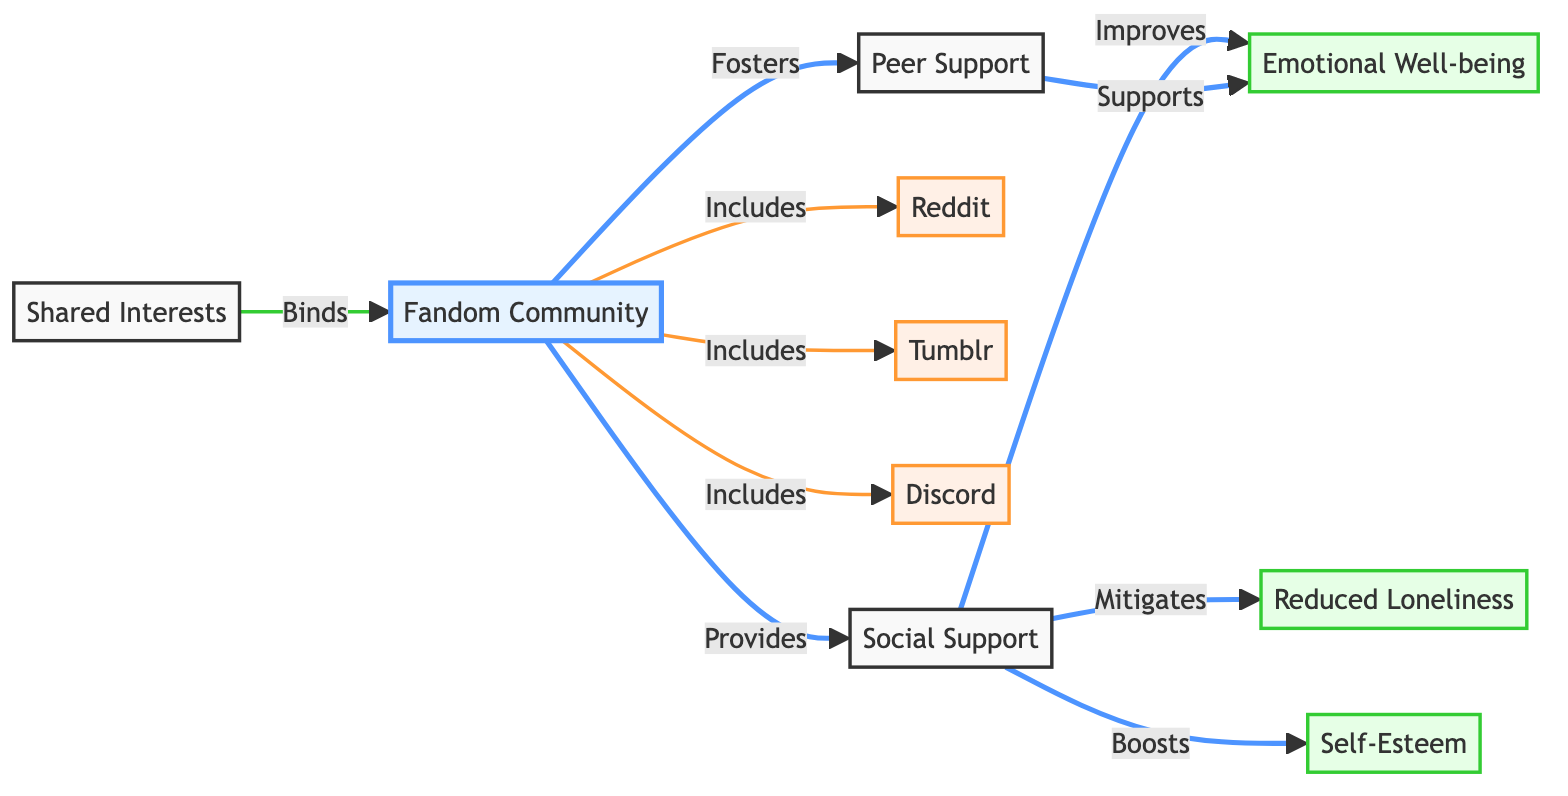What is the main focal point of the diagram? The diagram centers around the "Fandom Community," which is the primary node connected to various other elements. This can be identified as it is the first node listed and the starting point for multiple connections to other concepts.
Answer: Fandom Community How many benefits are identified in the diagram? To determine the number of benefits represented, we can count the nodes categorized as benefits. There are three benefits: "Emotional Well-being," "Self-Esteem," and "Reduced Loneliness." Thus, summing these nodes gives the total.
Answer: Three What type of support is indicated as being improved by social support in the diagram? The diagram shows the direct relationship where "Social Support" is indicated to "Improve" "Emotional Well-being." By following the connection from "Social Support," we can see the effect is on emotional well-being.
Answer: Emotional Well-being Which platforms are included in the fandom community? By examining the nodes connected to "Fandom Community," we can identify the platforms listed: "Reddit," "Tumblr," and "Discord." These platforms are explicitly marked as included within the community.
Answer: Reddit, Tumblr, Discord What effect does social support have on self-esteem? The diagram states that social support "Boosts" self-esteem. By following the arrow from "Social Support" to "Self-Esteem," we can see this direct relationship indicating the beneficial effect.
Answer: Boosts How does the fandom community help reduce feelings of loneliness? The connection present in the diagram shows that the "Social Support" from the fandom community "Mitigates" "Reduced Loneliness." To answer, we follow the path from the fandom community through social support to loneliness.
Answer: Mitigates Which term best describes how personal interests connect participants in the community? The term "Binds" is used in the diagram to connect "Shared Interests" with the "Fandom Community." This means that shared interests create strong connections among participants.
Answer: Binds How does peer support relate to emotional well-being? The diagram indicates that "Peer Support" "Supports" "Emotional Well-being." We can deduce that through the relationship paths, peer support is shown to positively affect emotional well-being thus providing an understanding of their connection.
Answer: Supports 